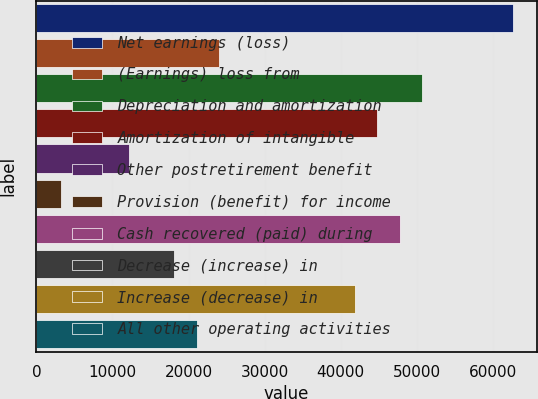Convert chart to OTSL. <chart><loc_0><loc_0><loc_500><loc_500><bar_chart><fcel>Net earnings (loss)<fcel>(Earnings) loss from<fcel>Depreciation and amortization<fcel>Amortization of intangible<fcel>Other postretirement benefit<fcel>Provision (benefit) for income<fcel>Cash recovered (paid) during<fcel>Decrease (increase) in<fcel>Increase (decrease) in<fcel>All other operating activities<nl><fcel>62640.9<fcel>24032.2<fcel>50761.3<fcel>44821.5<fcel>12152.6<fcel>3242.9<fcel>47791.4<fcel>18092.4<fcel>41851.6<fcel>21062.3<nl></chart> 